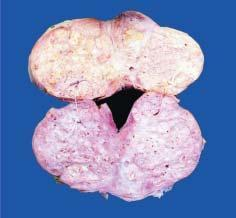what does sectioned surface of enlarged prostate show?
Answer the question using a single word or phrase. Soft to firm 